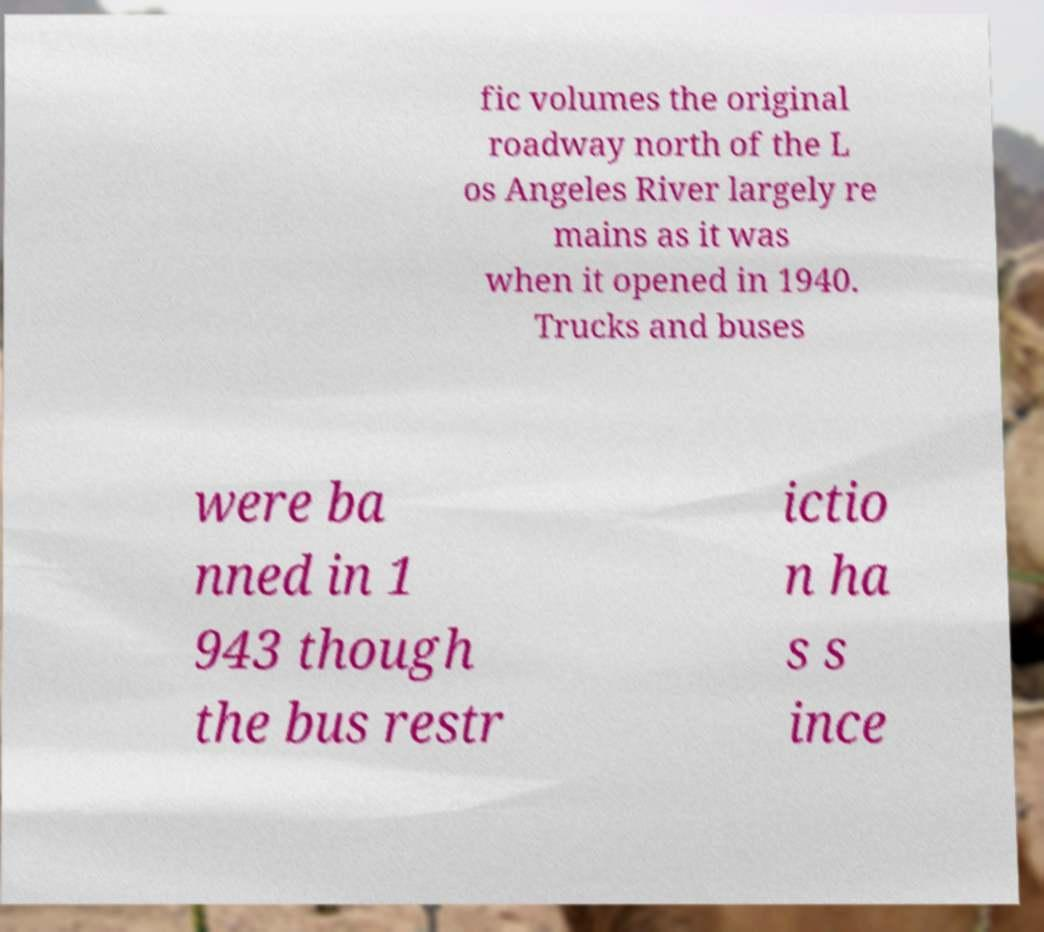For documentation purposes, I need the text within this image transcribed. Could you provide that? fic volumes the original roadway north of the L os Angeles River largely re mains as it was when it opened in 1940. Trucks and buses were ba nned in 1 943 though the bus restr ictio n ha s s ince 